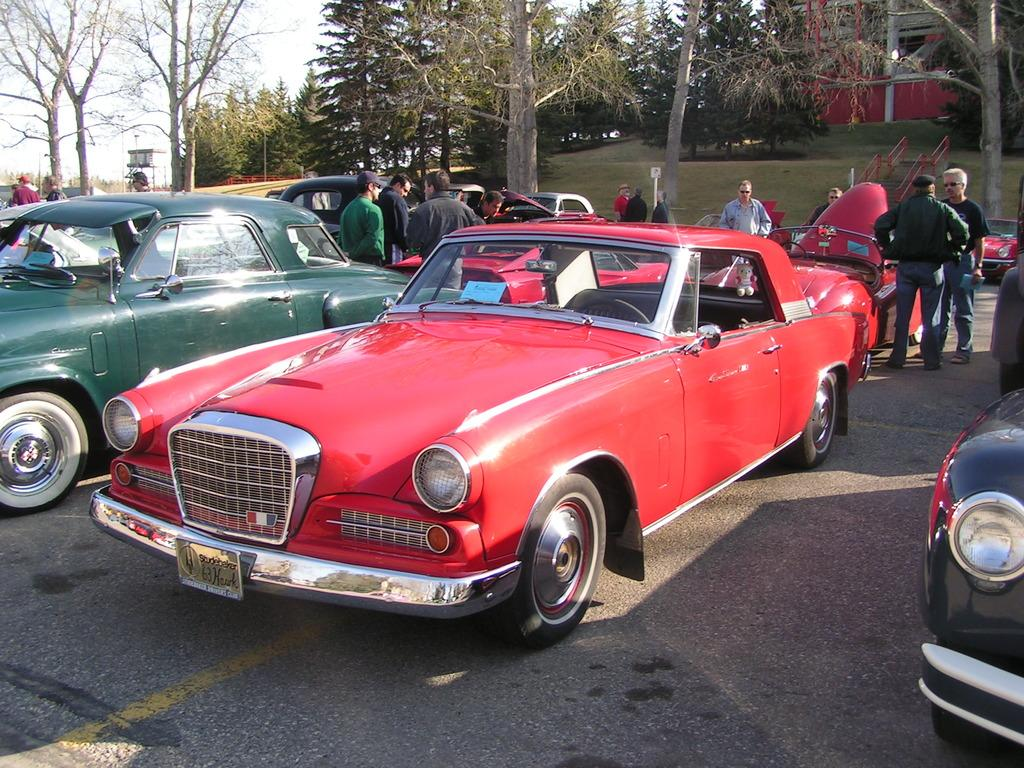What type of vehicles can be seen in the image? There are cars in the image. What are the people in the image doing? There is a group of people standing on the road. What type of vegetation is present in the image? Trees and grass are visible in the image. What architectural feature can be seen in the image? There are steps in the image. What type of building is in the image? There is a house in the image. What is visible in the background of the image? The sky is visible in the background of the image. What type of note is being played by the vessel in the image? There is no vessel or note being played in the image; it features cars, a group of people, trees, grass, steps, a house, and the sky. What color is the yarn used to knit the sweater in the image? There is no sweater or yarn present in the image. 